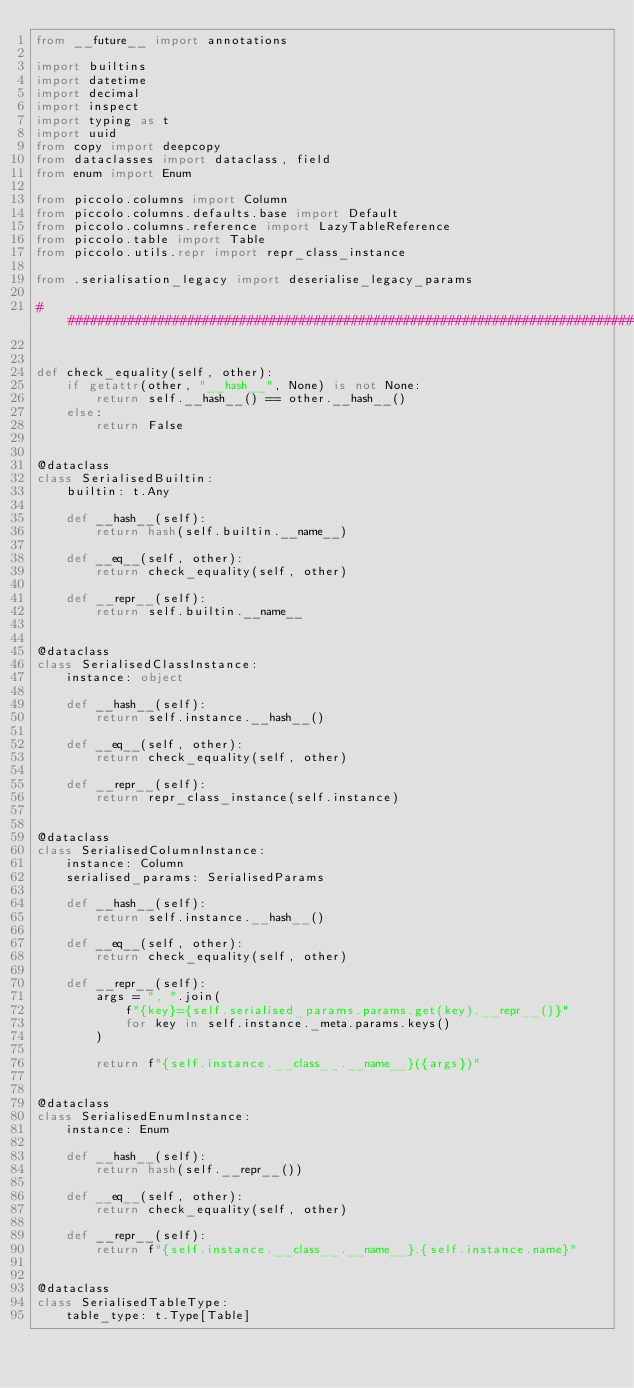<code> <loc_0><loc_0><loc_500><loc_500><_Python_>from __future__ import annotations

import builtins
import datetime
import decimal
import inspect
import typing as t
import uuid
from copy import deepcopy
from dataclasses import dataclass, field
from enum import Enum

from piccolo.columns import Column
from piccolo.columns.defaults.base import Default
from piccolo.columns.reference import LazyTableReference
from piccolo.table import Table
from piccolo.utils.repr import repr_class_instance

from .serialisation_legacy import deserialise_legacy_params

###############################################################################


def check_equality(self, other):
    if getattr(other, "__hash__", None) is not None:
        return self.__hash__() == other.__hash__()
    else:
        return False


@dataclass
class SerialisedBuiltin:
    builtin: t.Any

    def __hash__(self):
        return hash(self.builtin.__name__)

    def __eq__(self, other):
        return check_equality(self, other)

    def __repr__(self):
        return self.builtin.__name__


@dataclass
class SerialisedClassInstance:
    instance: object

    def __hash__(self):
        return self.instance.__hash__()

    def __eq__(self, other):
        return check_equality(self, other)

    def __repr__(self):
        return repr_class_instance(self.instance)


@dataclass
class SerialisedColumnInstance:
    instance: Column
    serialised_params: SerialisedParams

    def __hash__(self):
        return self.instance.__hash__()

    def __eq__(self, other):
        return check_equality(self, other)

    def __repr__(self):
        args = ", ".join(
            f"{key}={self.serialised_params.params.get(key).__repr__()}"
            for key in self.instance._meta.params.keys()
        )

        return f"{self.instance.__class__.__name__}({args})"


@dataclass
class SerialisedEnumInstance:
    instance: Enum

    def __hash__(self):
        return hash(self.__repr__())

    def __eq__(self, other):
        return check_equality(self, other)

    def __repr__(self):
        return f"{self.instance.__class__.__name__}.{self.instance.name}"


@dataclass
class SerialisedTableType:
    table_type: t.Type[Table]
</code> 